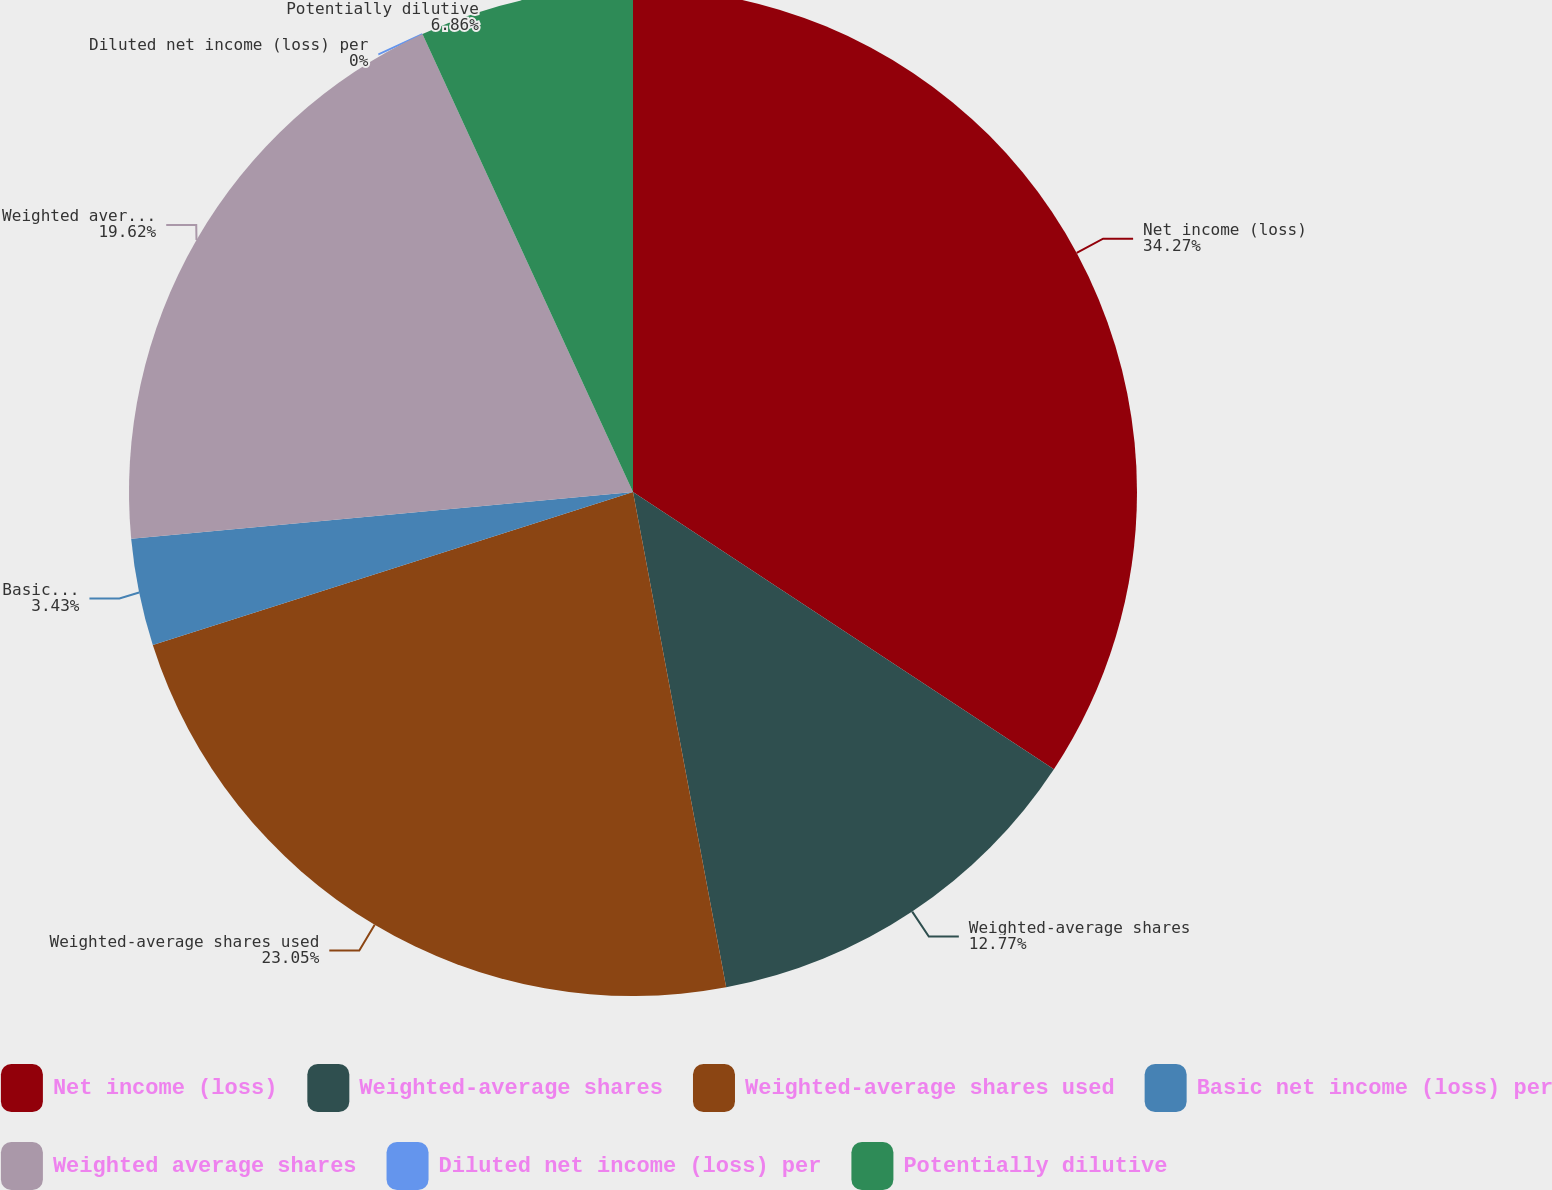<chart> <loc_0><loc_0><loc_500><loc_500><pie_chart><fcel>Net income (loss)<fcel>Weighted-average shares<fcel>Weighted-average shares used<fcel>Basic net income (loss) per<fcel>Weighted average shares<fcel>Diluted net income (loss) per<fcel>Potentially dilutive<nl><fcel>34.27%<fcel>12.77%<fcel>23.05%<fcel>3.43%<fcel>19.62%<fcel>0.0%<fcel>6.86%<nl></chart> 